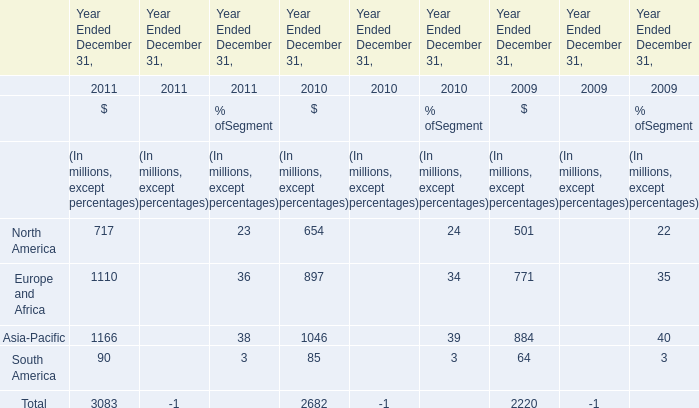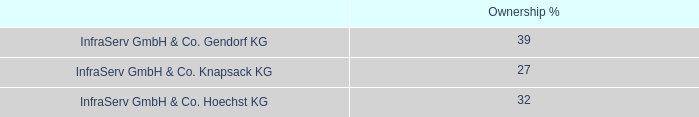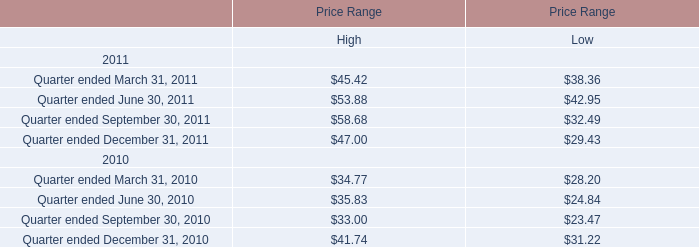what was the percentage growth in the cash dividends from 2009 to 2010 
Computations: ((71 - 56) / 56)
Answer: 0.26786. 